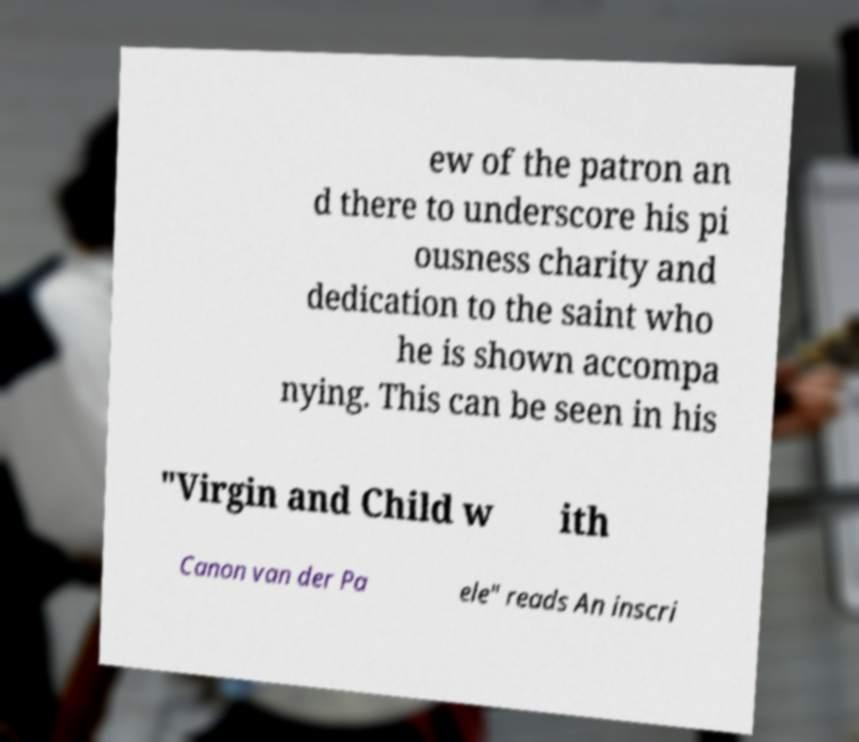Can you read and provide the text displayed in the image?This photo seems to have some interesting text. Can you extract and type it out for me? ew of the patron an d there to underscore his pi ousness charity and dedication to the saint who he is shown accompa nying. This can be seen in his "Virgin and Child w ith Canon van der Pa ele" reads An inscri 